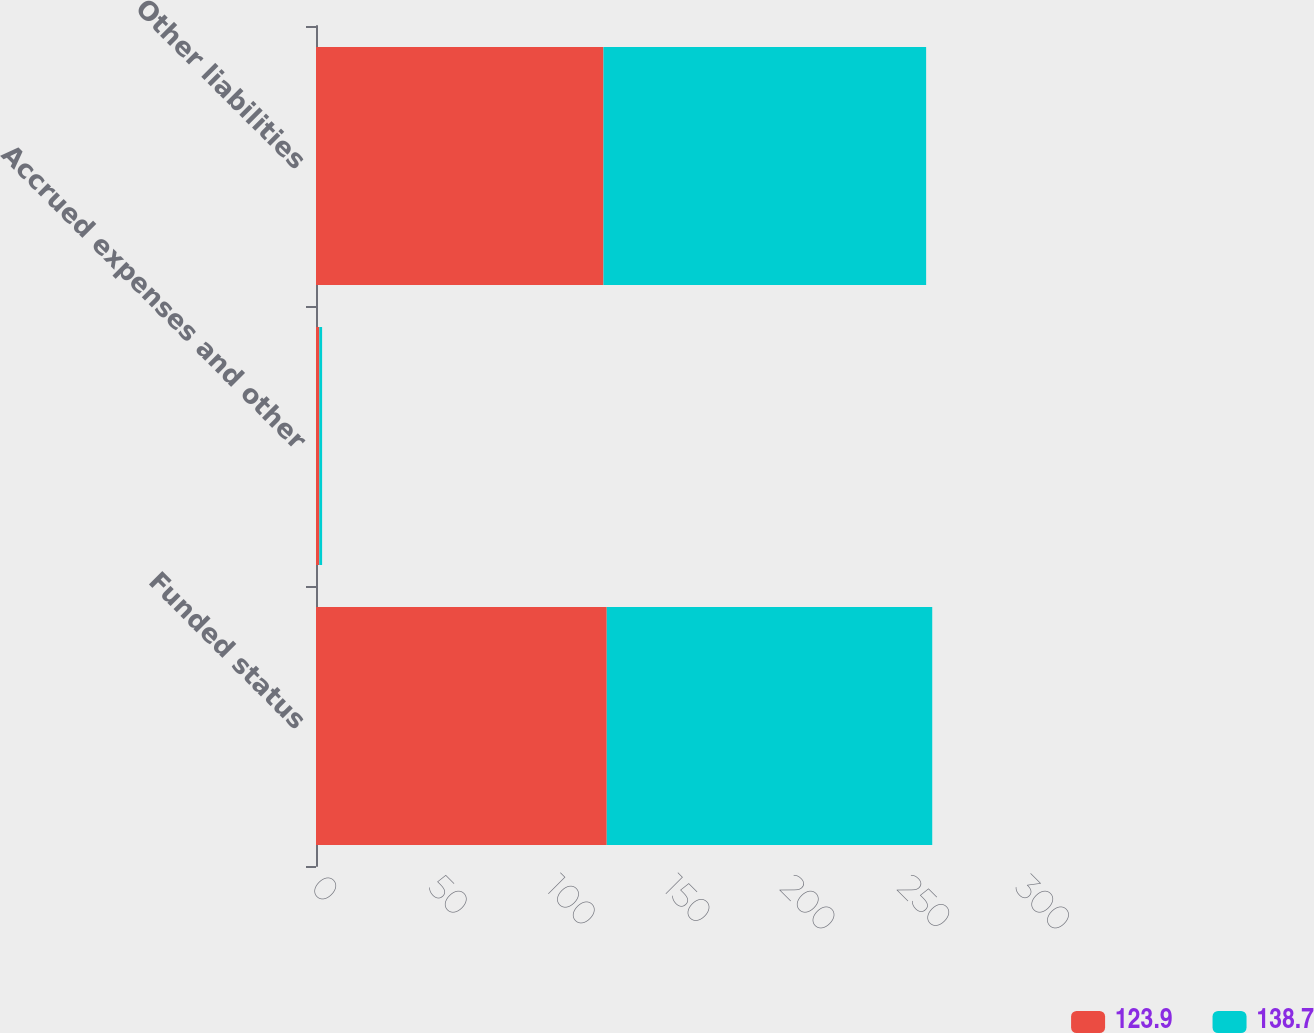Convert chart to OTSL. <chart><loc_0><loc_0><loc_500><loc_500><stacked_bar_chart><ecel><fcel>Funded status<fcel>Accrued expenses and other<fcel>Other liabilities<nl><fcel>123.9<fcel>123.9<fcel>1.4<fcel>122.5<nl><fcel>138.7<fcel>138.7<fcel>1.2<fcel>137.5<nl></chart> 